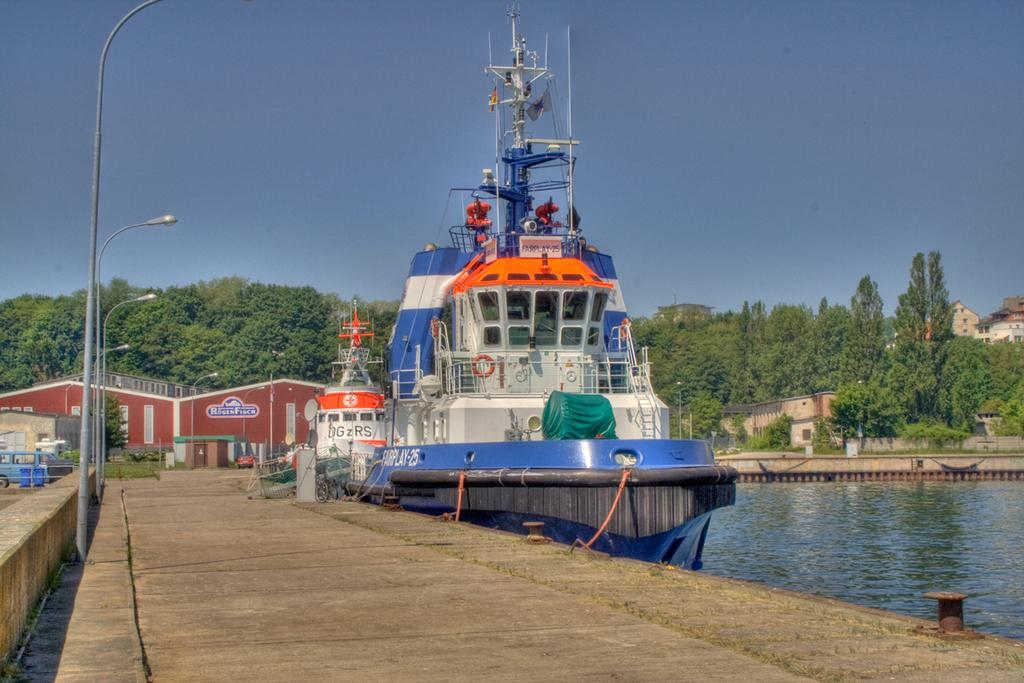What is in the water in the image? There are boats in the water. What structures can be seen in the image? There are buildings visible in the image. What type of vehicle is parked in the image? A car is parked in the image. What type of vegetation is present in the image? There are trees in the image. What type of lighting is present in the image? There are pole lights in the image. What is the color of the sky in the image? The sky is blue in the image. How many branches can be seen on the head of the cow in the image? There are no cows present in the image, so there are no branches on the head of a cow to count. 